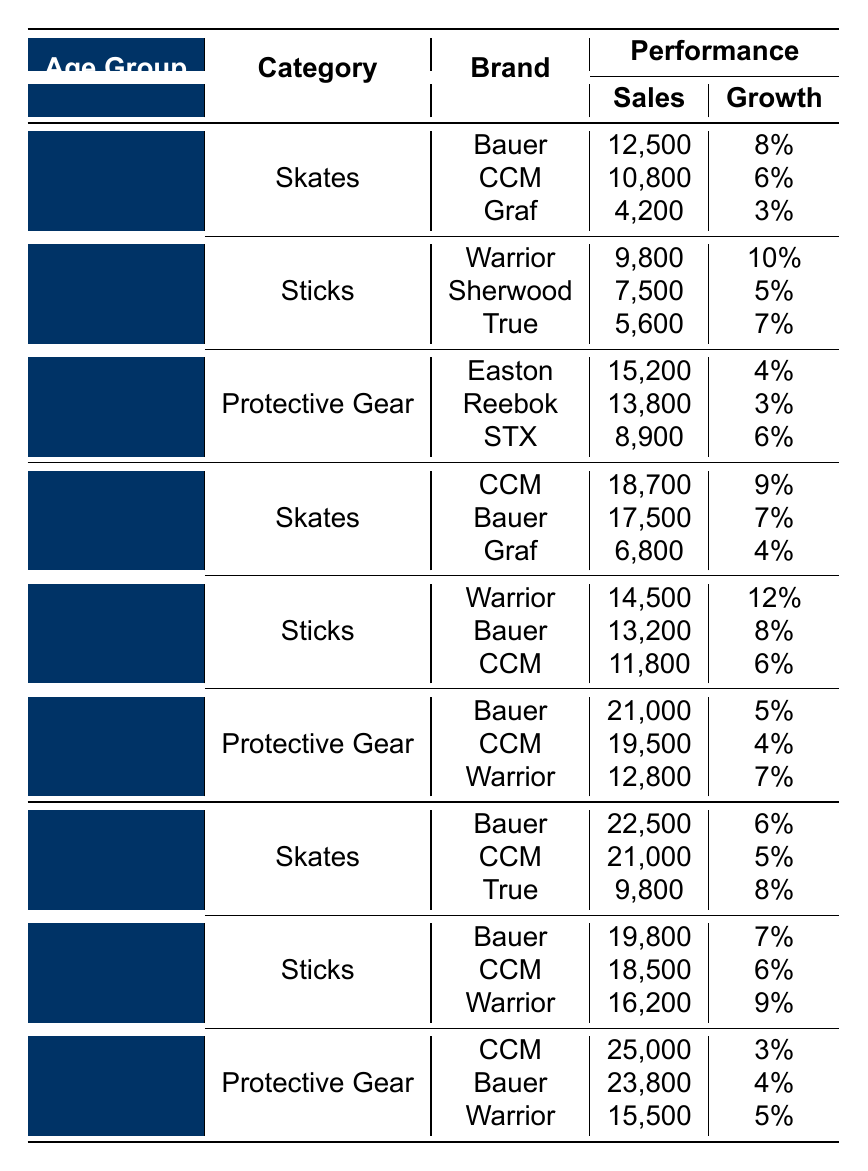What hockey stick brand sold the most in the Youth age group? In the Youth age group, under the Sticks category, Warrior sold 9,800 units, which is the highest compared to Sherwood and True.
Answer: Warrior Which category had the highest sales in the Junior age group? In the Junior age group, under Protective Gear, Bauer had sales of 21,000, which is greater than the sales in Skates (CCM sold 18,700) and Sticks (Warrior sold 14,500).
Answer: Protective Gear What is the total sales of Bauer hockey skates across all age groups? Bauer sales in Youth are 12,500, in Junior are 17,500, and in Adult are 22,500. Adding these gives 12,500 + 17,500 + 22,500 = 52,500.
Answer: 52,500 Which age group saw the highest growth percentage in the Sticks category? In the Sticks category for Youth, the highest growth is 10% for Warrior, whereas in Junior, it's 12% for Warrior as well, making Junior the highest.
Answer: Junior Is CCM the brand with the highest sales in the Adult Protective Gear category? No, in the Adult Protective Gear category, CCM sold 25,000, which is higher than Bauer's 23,800, making it indeed the highest.
Answer: Yes What is the average sales figure for sticks across all age groups? The sales for sticks are 9,800 (Youth) + 14,500 (Junior) + 19,800 (Adult) = 44,100 total. Dividing by 3 groups gives an average of 44,100/3 = 14,700.
Answer: 14,700 Which brand had the lowest sales in the Youth category for Protective Gear? In the Youth category for Protective Gear, STX had the lowest sales at 8,900 compared to Easton's 15,200 and Reebok's 13,800.
Answer: STX How much more did Bauer sell compared to CCM in Junior Protective Gear? Bauer sales in Junior Protective Gear are 21,000, while CCM sold 19,500. The difference is 21,000 - 19,500 = 1,500.
Answer: 1,500 In which category did True show the highest sales among all age groups? True had the highest sales in Adult Skates with 9,800, compared to its sales in Youth and Junior categories, which were lower.
Answer: Adult Skates What is the total sales for Warrior sticks in all age groups combined? Warrior sticks sold 9,800 (Youth), 14,500 (Junior), and 16,200 (Adult), giving a total of 9,800 + 14,500 + 16,200 = 40,500.
Answer: 40,500 